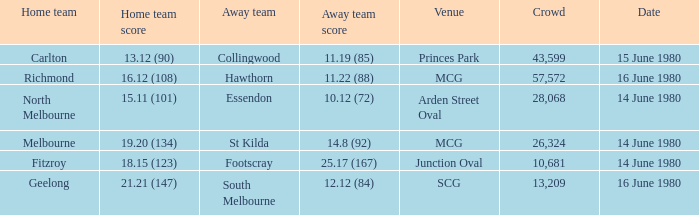On what date the footscray's away game? 14 June 1980. 